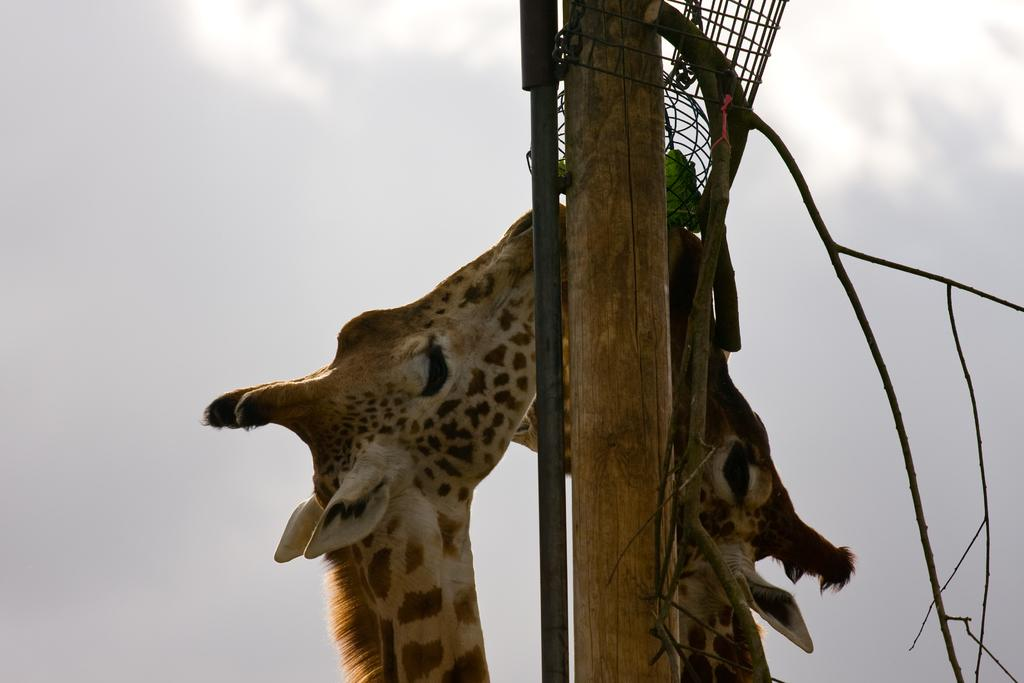How many giraffes are in the image? There are two giraffes in the image. What are the giraffes doing in the image? The giraffes appear to be eating. What objects can be seen in the image besides the giraffes? There is a wooden block and a metal pole in the image. What can be seen in the background of the image? The sky is visible in the background of the image. What type of store can be seen in the image? There is no store present in the image; it features two giraffes, a wooden block, a metal pole, and a sky background. What color is the silver object in the image? There is no silver object present in the image. 